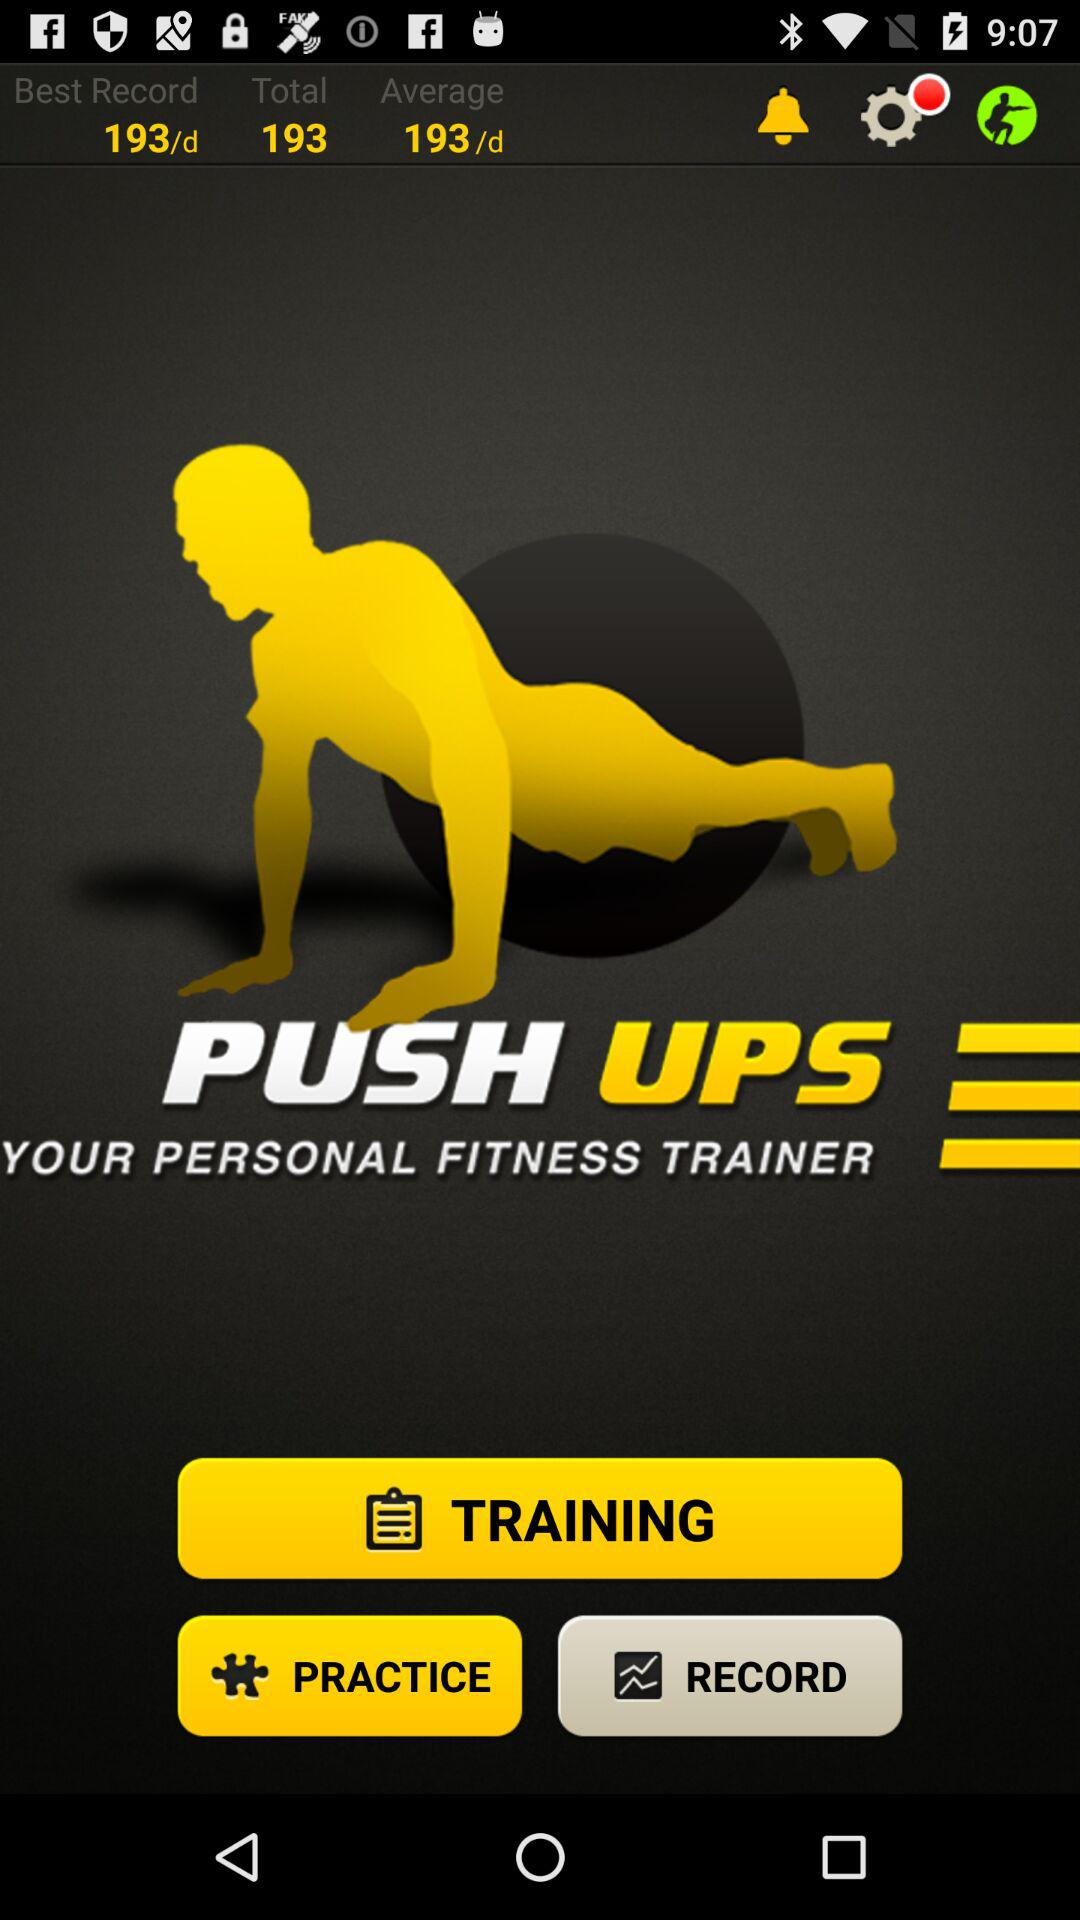What is the average per day? The average per day is 193. 